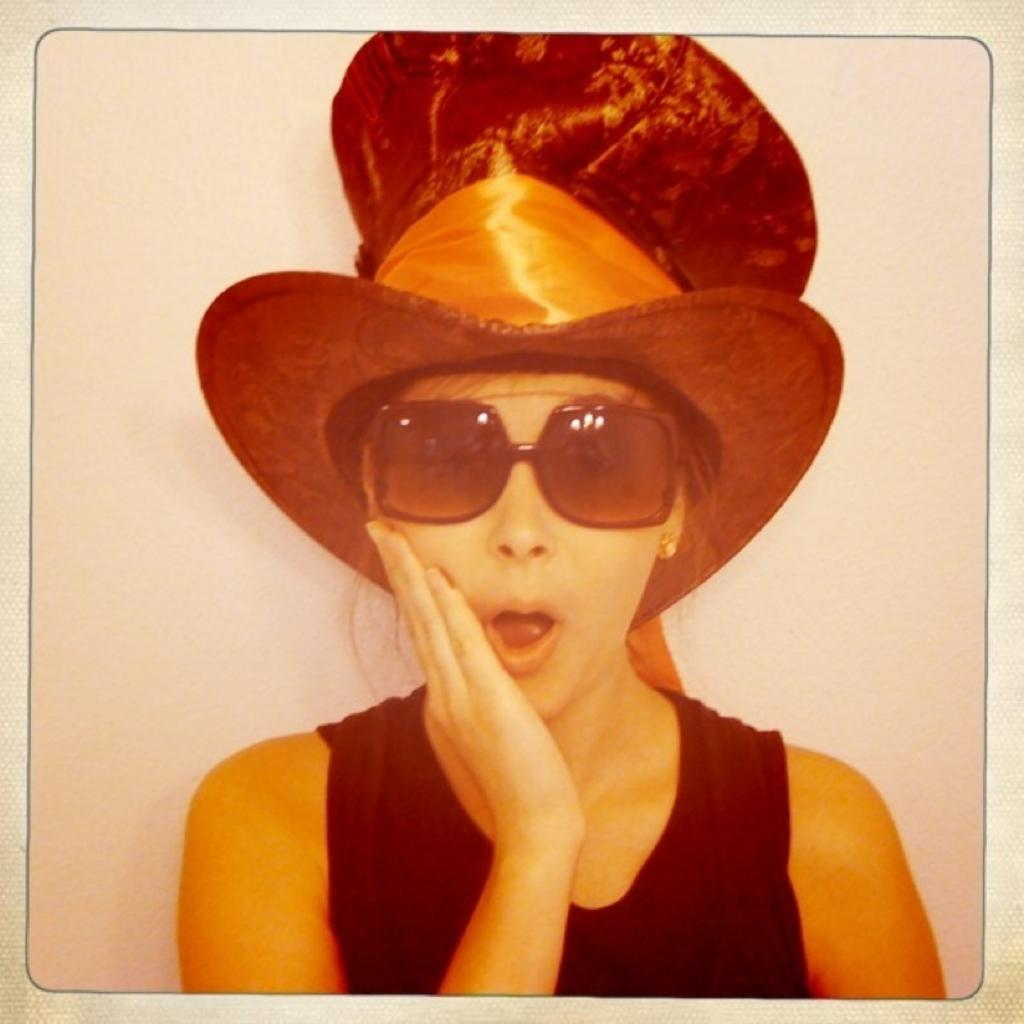Who is the main subject in the image? There is a lady in the center of the image. What is the lady wearing on her head? The lady is wearing a hat. What can be seen in the background of the image? There is a wall in the background of the image. What type of coat is the horse wearing in the image? There is no horse present in the image, so it is not possible to determine what type of coat the horse might be wearing. 